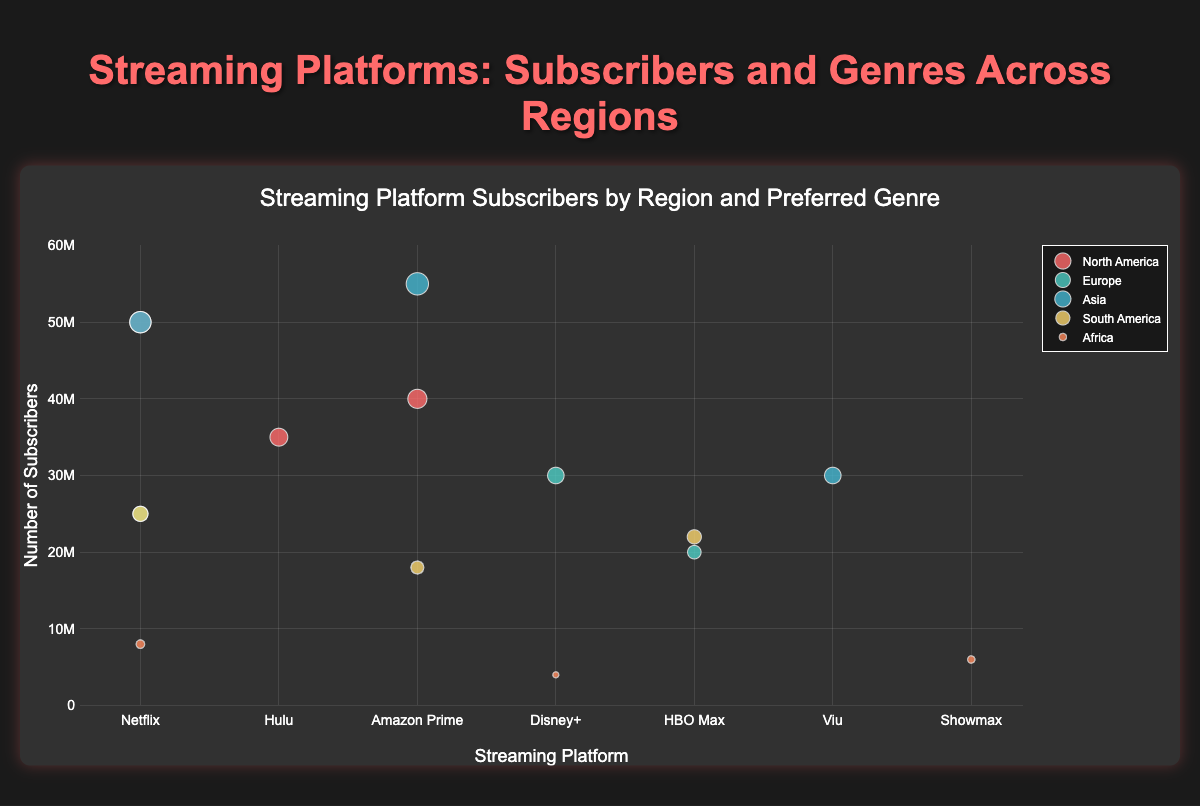Which region has the most significant number of subscribers for the Action genre? Looking at the plot, the Action genre in Asia has the largest marker size representing the highest number of subscribers.
Answer: Asia How many subscribers prefer Drama in North America? Locate the marker for North America and Drama. The hover text or size of the marker indicates 50,000,000 subscribers.
Answer: 50,000,000 What is the total number of subscribers for Netflix in all regions combined? Add the subscribers for Netflix across all regions: 50,000,000 (NA) + 25,000,000 (EU) + 50,000,000 (Asia) + 25,000,000 (SA) + 8,000,000 (Africa) = 158,000,000.
Answer: 158,000,000 Which streaming platform has the most subscribers in Europe? Compare the marker sizes for different platforms in Europe. Disney+ with 30,000,000 subscribers has the largest marker.
Answer: Disney+ Which genre is preferred by the second-largest subscriber group in Asia? In Asia, the second-largest marker after Action (Amazon Prime) is Drama (Netflix) with 50,000,000 subscribers.
Answer: Drama What is the average number of subscribers for Comedy in all regions combined? Combine subscribers of Comedy in North America (35,000,000) and South America (25,000,000) and then divide by the count (total is 60,000,000, count is 2). 60,000,000 / 2 = 30,000,000.
Answer: 30,000,000 How does Africa's Documentary subscribers compare to North America's Comedy subscribers in absolute numbers? Africa's Documentary (Netflix) has 8,000,000 subscribers, and North America's Comedy (Hulu) has 35,000,000 subscribers. The difference is 35,000,000 - 8,000,000 = 27,000,000.
Answer: 27,000,000 Which region prefers Historical genre? The plot shows Europe has a marker with Historical genre on Disney+.
Answer: Europe In South America, what is the total number of subscribers who prefer Drama or Action? Add the subscribers who prefer Drama (HBO Max) and Action (Amazon Prime) in South America: 22,000,000 + 18,000,000 = 40,000,000.
Answer: 40,000,000 